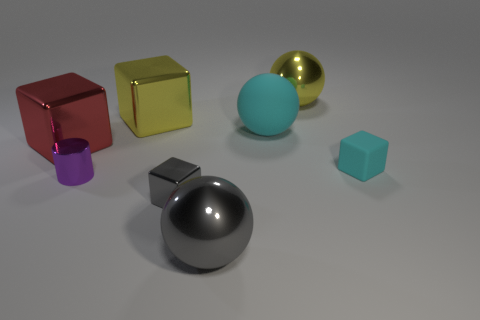There is a rubber thing that is the same color as the matte ball; what size is it?
Make the answer very short. Small. Are there an equal number of large yellow metallic spheres behind the yellow shiny ball and blue matte cylinders?
Your answer should be compact. Yes. What number of things are rubber spheres or objects that are in front of the large cyan rubber ball?
Your answer should be compact. 6. Is the color of the tiny matte block the same as the big rubber object?
Your answer should be compact. Yes. Are there any purple cylinders made of the same material as the big yellow sphere?
Offer a very short reply. Yes. What color is the small shiny thing that is the same shape as the small rubber object?
Ensure brevity in your answer.  Gray. Are the small gray block and the cube that is on the right side of the gray shiny ball made of the same material?
Ensure brevity in your answer.  No. The gray shiny thing that is behind the large object that is in front of the small purple metallic thing is what shape?
Your response must be concise. Cube. There is a red block in front of the cyan matte sphere; is it the same size as the tiny purple cylinder?
Provide a short and direct response. No. What number of other objects are there of the same shape as the purple metallic object?
Give a very brief answer. 0. 